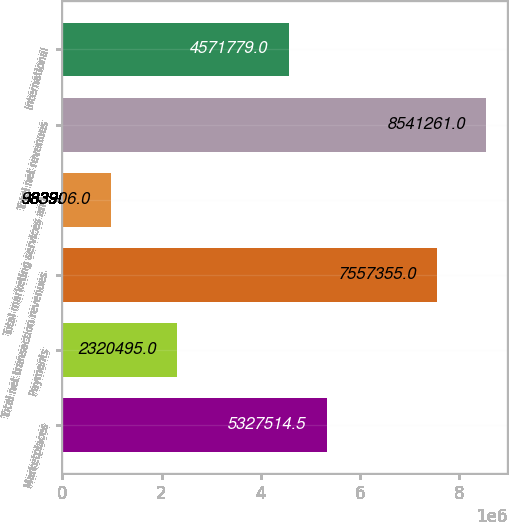<chart> <loc_0><loc_0><loc_500><loc_500><bar_chart><fcel>Marketplaces<fcel>Payments<fcel>Total net transaction revenues<fcel>Total marketing services and<fcel>Total net revenues<fcel>International<nl><fcel>5.32751e+06<fcel>2.3205e+06<fcel>7.55736e+06<fcel>983906<fcel>8.54126e+06<fcel>4.57178e+06<nl></chart> 